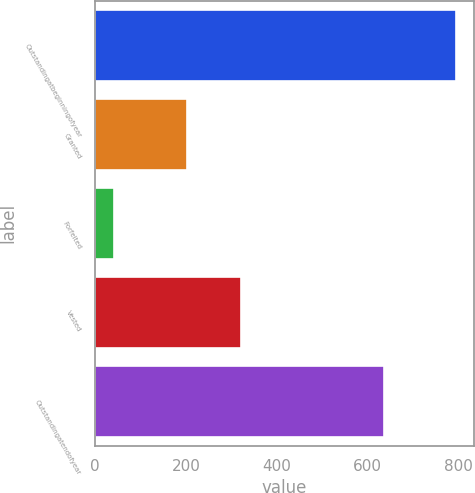<chart> <loc_0><loc_0><loc_500><loc_500><bar_chart><fcel>Outstandingatbeginningofyear<fcel>Granted<fcel>Forfeited<fcel>Vested<fcel>Outstandingatendofyear<nl><fcel>795<fcel>203<fcel>41<fcel>321<fcel>636<nl></chart> 